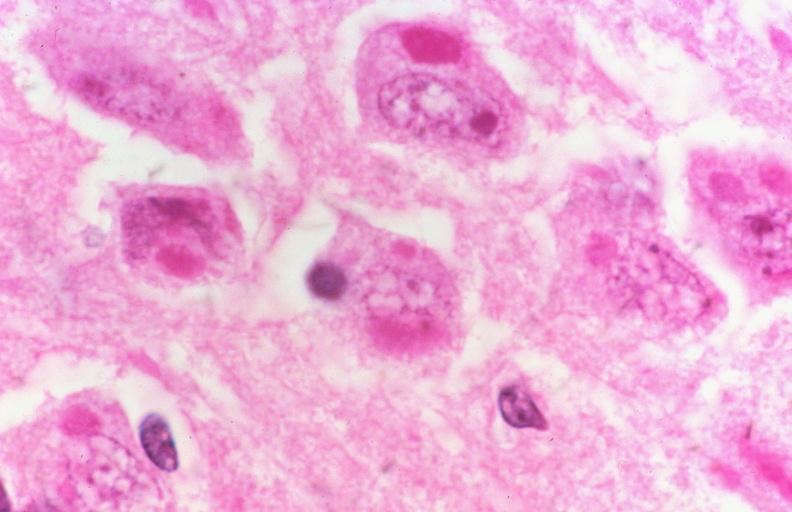does section of spleen through hilum show rabies, negri bodies?
Answer the question using a single word or phrase. No 